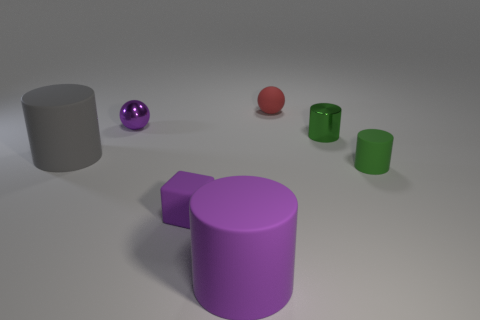What might the size relationships between objects tell us about their distance or scale? The size relationships between objects can give us clues about their relative distance from the viewer or their actual scale. Objects that are larger in the foreground, like the purple cylinder, seem closer to us, while smaller objects, such as the small purple ball, might be interpreted as being further away or simply smaller in size. However, without additional context or known reference points in the image, it's challenging to determine the absolute scale of these objects; they could be miniature models or full-sized objects in an open space. 